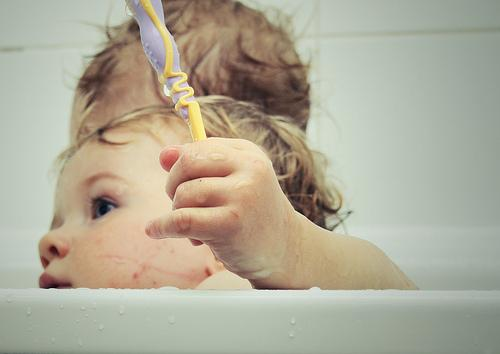What is the baby sitting holding?

Choices:
A) apple
B) pumpkin
C) toothbrush
D) his foot toothbrush 